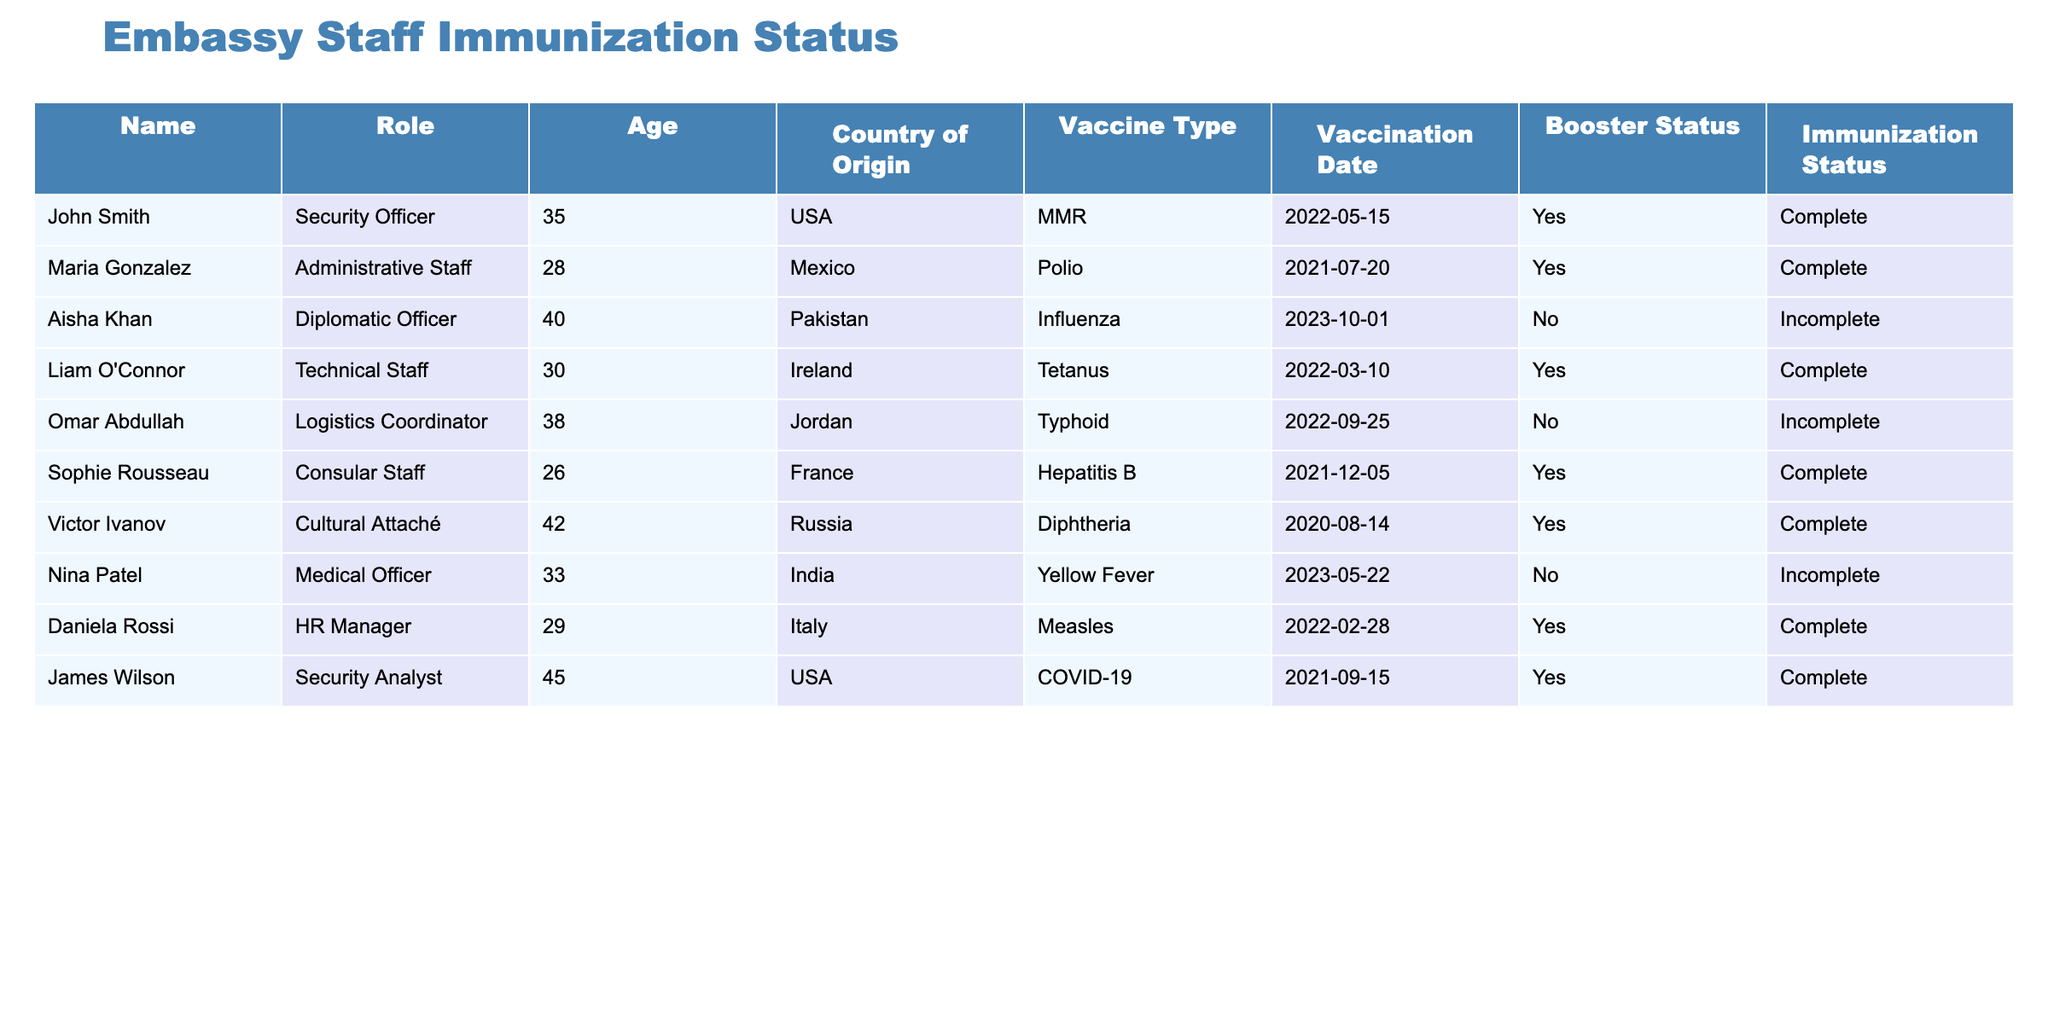What is the immunization status of Aisha Khan? Aisha Khan is listed in the table under the "Name" column. When checking the corresponding "Immunization Status" column, it shows "Incomplete."
Answer: Incomplete How many staff members have received a booster shot? To find this, I will count the "Yes" entries in the "Booster Status" column. I see that 5 entries indicate "Yes."
Answer: 5 Is Nina Patel fully immunized? Checking Nina Patel's "Immunization Status" reveals that it is marked as "Incomplete."
Answer: No What vaccine did Maria Gonzalez receive, and when was it administered? Maria Gonzalez's row shows she received the "Polio" vaccine, and the "Vaccination Date" listed is "2021-07-20."
Answer: Polio, 2021-07-20 Among the embassy staff listed, who is the youngest, and what is their role? By inspecting the "Age" column, the youngest individual is Sophie Rousseau, who is 26 years old. Her role is "Consular Staff."
Answer: Sophie Rousseau, Consular Staff What is the total number of incomplete immunizations? Count the total "Incomplete" entries in the "Immunization Status" column. There are 4 entries marked as "Incomplete."
Answer: 4 Is there anyone from the USA with a complete immunization status? I check each entry from the USA. Both John Smith and James Wilson are from the USA, and both have a "Complete" status.
Answer: Yes How many different vaccine types are listed in the table? I will check the "Vaccine Type" column and count the unique entries. There are 9 different types listed.
Answer: 9 What percentage of the embassy staff is fully vaccinated? There are 10 staff members in total, and 6 have a "Complete" status. The percentage is calculated as (6/10) * 100 = 60%.
Answer: 60% 